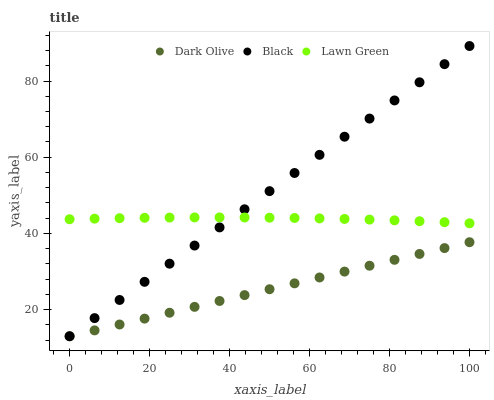Does Dark Olive have the minimum area under the curve?
Answer yes or no. Yes. Does Black have the maximum area under the curve?
Answer yes or no. Yes. Does Black have the minimum area under the curve?
Answer yes or no. No. Does Dark Olive have the maximum area under the curve?
Answer yes or no. No. Is Dark Olive the smoothest?
Answer yes or no. Yes. Is Lawn Green the roughest?
Answer yes or no. Yes. Is Black the smoothest?
Answer yes or no. No. Is Black the roughest?
Answer yes or no. No. Does Dark Olive have the lowest value?
Answer yes or no. Yes. Does Black have the highest value?
Answer yes or no. Yes. Does Dark Olive have the highest value?
Answer yes or no. No. Is Dark Olive less than Lawn Green?
Answer yes or no. Yes. Is Lawn Green greater than Dark Olive?
Answer yes or no. Yes. Does Dark Olive intersect Black?
Answer yes or no. Yes. Is Dark Olive less than Black?
Answer yes or no. No. Is Dark Olive greater than Black?
Answer yes or no. No. Does Dark Olive intersect Lawn Green?
Answer yes or no. No. 